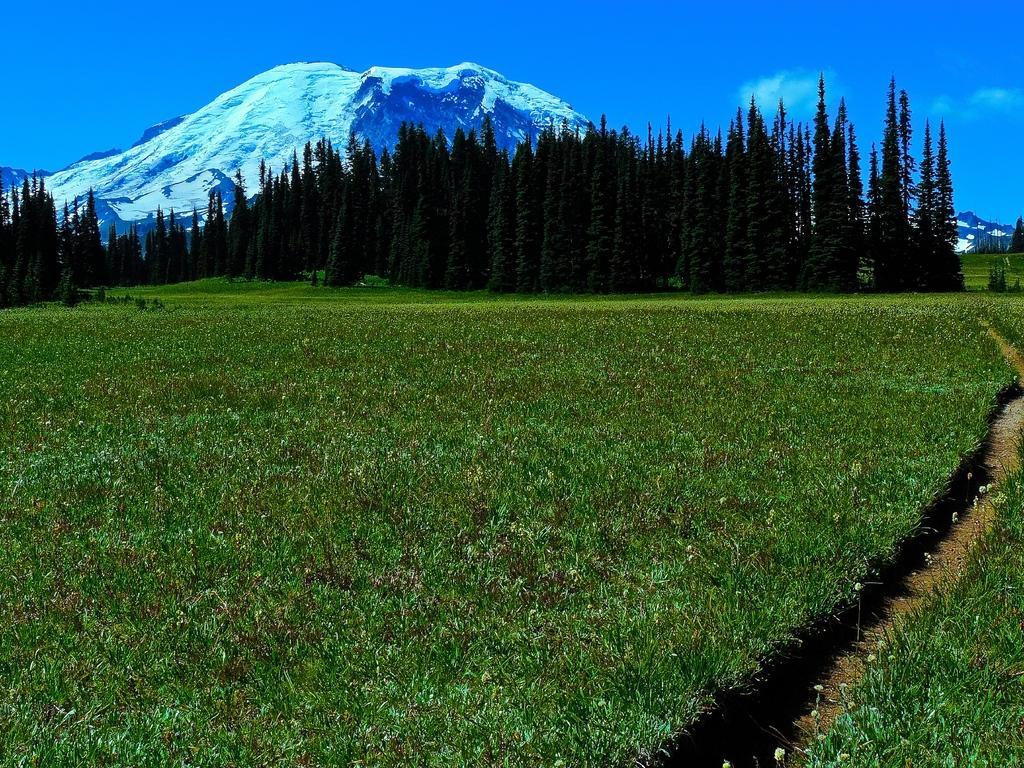Can you describe this image briefly? In this image we can see some trees, plants, grass and mountains, in the background, we can see the sky with clouds. 